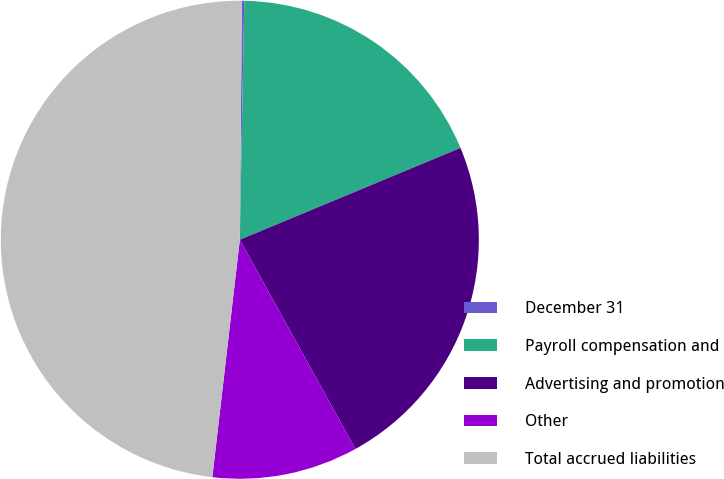Convert chart to OTSL. <chart><loc_0><loc_0><loc_500><loc_500><pie_chart><fcel>December 31<fcel>Payroll compensation and<fcel>Advertising and promotion<fcel>Other<fcel>Total accrued liabilities<nl><fcel>0.16%<fcel>18.43%<fcel>23.24%<fcel>9.87%<fcel>48.3%<nl></chart> 